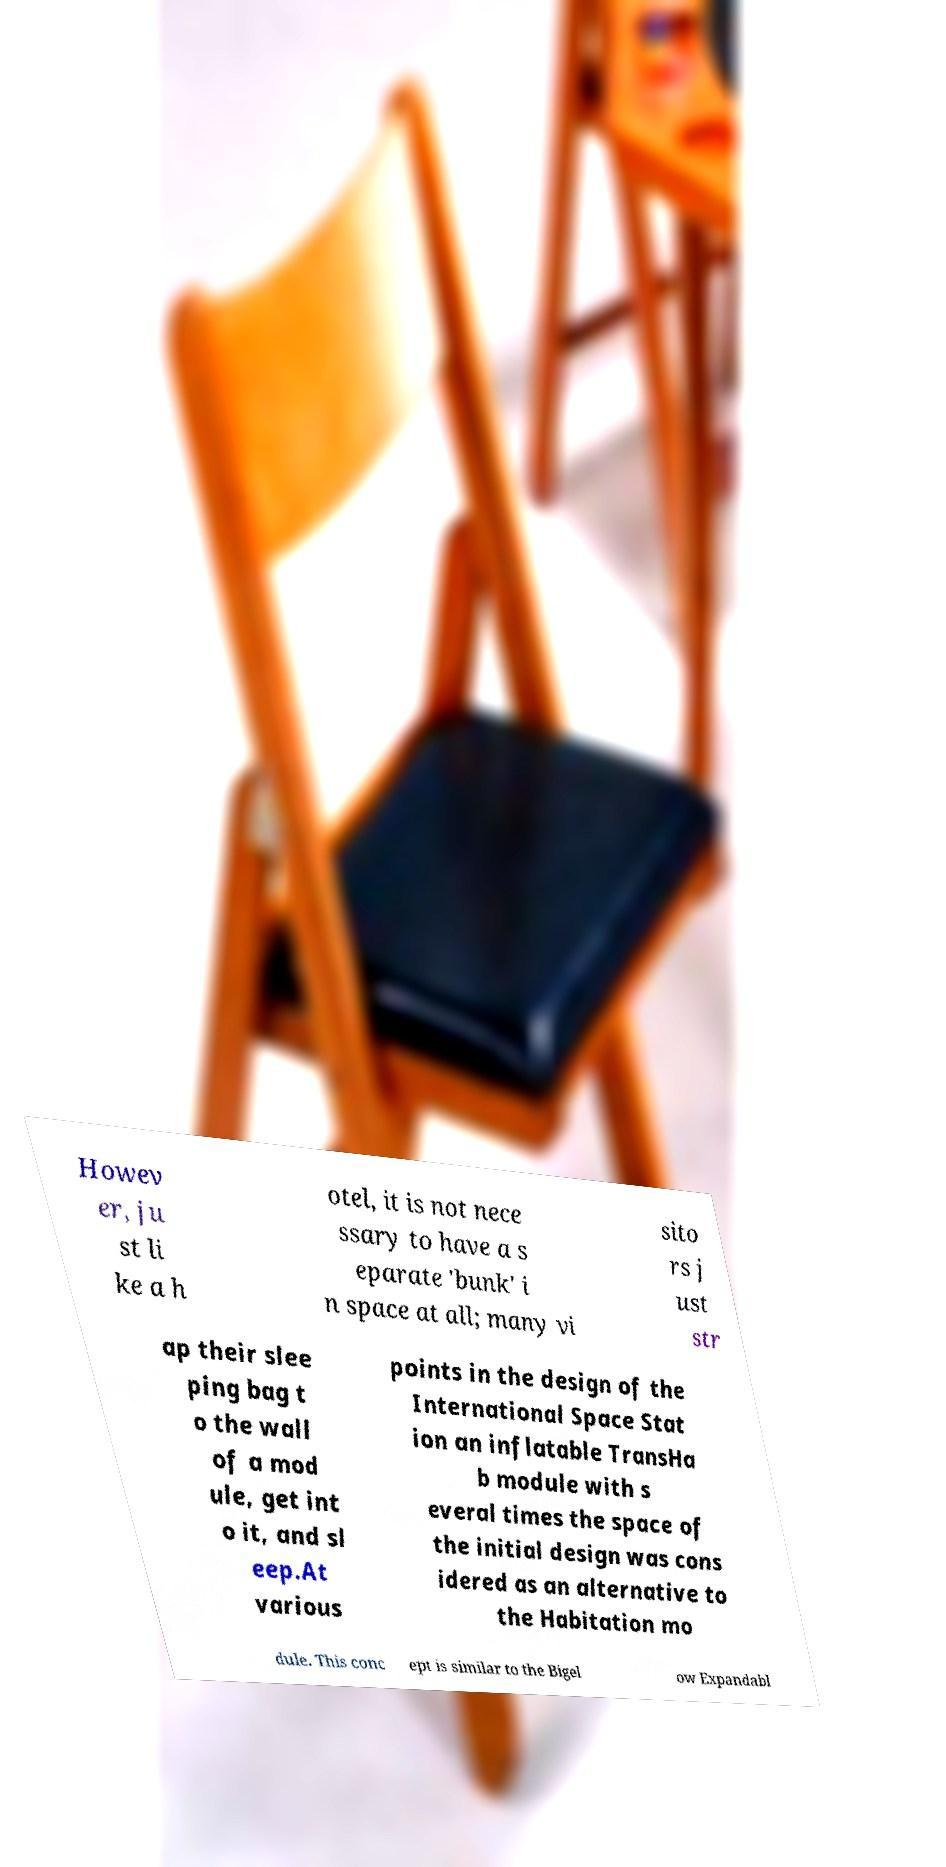Can you accurately transcribe the text from the provided image for me? Howev er, ju st li ke a h otel, it is not nece ssary to have a s eparate 'bunk' i n space at all; many vi sito rs j ust str ap their slee ping bag t o the wall of a mod ule, get int o it, and sl eep.At various points in the design of the International Space Stat ion an inflatable TransHa b module with s everal times the space of the initial design was cons idered as an alternative to the Habitation mo dule. This conc ept is similar to the Bigel ow Expandabl 